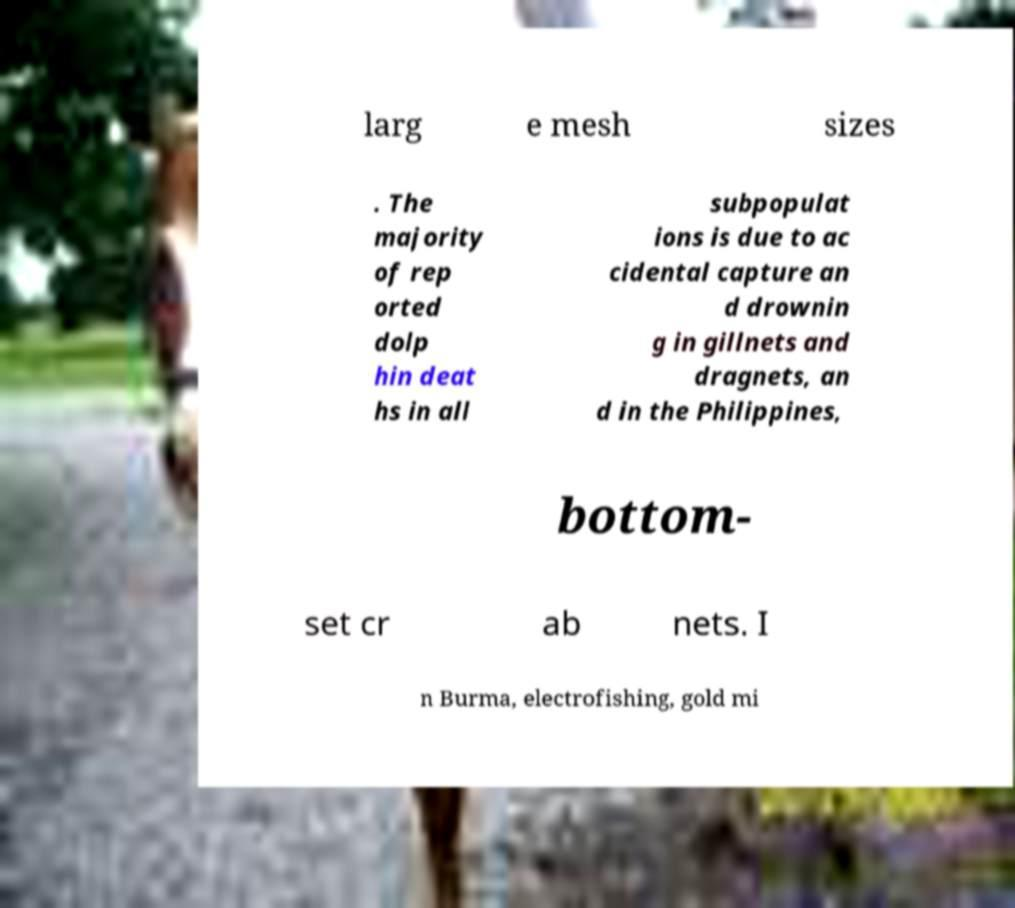Can you read and provide the text displayed in the image?This photo seems to have some interesting text. Can you extract and type it out for me? larg e mesh sizes . The majority of rep orted dolp hin deat hs in all subpopulat ions is due to ac cidental capture an d drownin g in gillnets and dragnets, an d in the Philippines, bottom- set cr ab nets. I n Burma, electrofishing, gold mi 